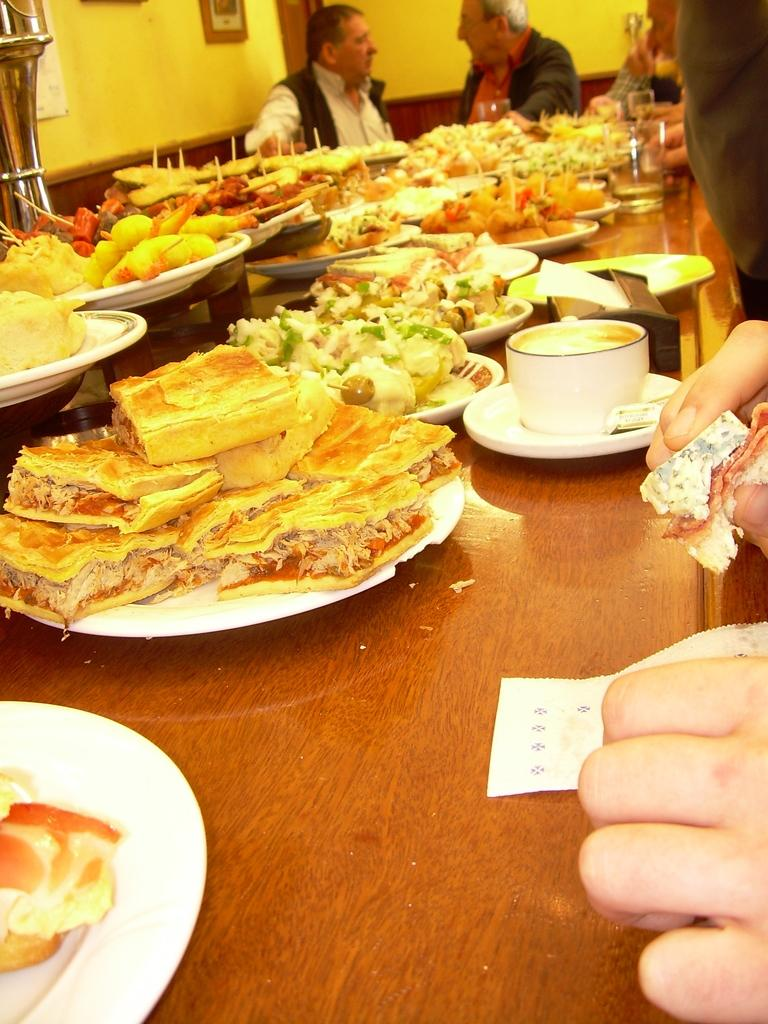What are the people in the image doing? The people in the image are seated. What is on the plates in the image? There is food in plates in the image. What can be seen on the table in the image? There are teacups on the table in the image. What type of riddle is being solved by the people in the image? There is no riddle present in the image; the people are simply seated and there is food in plates and teacups on the table. 